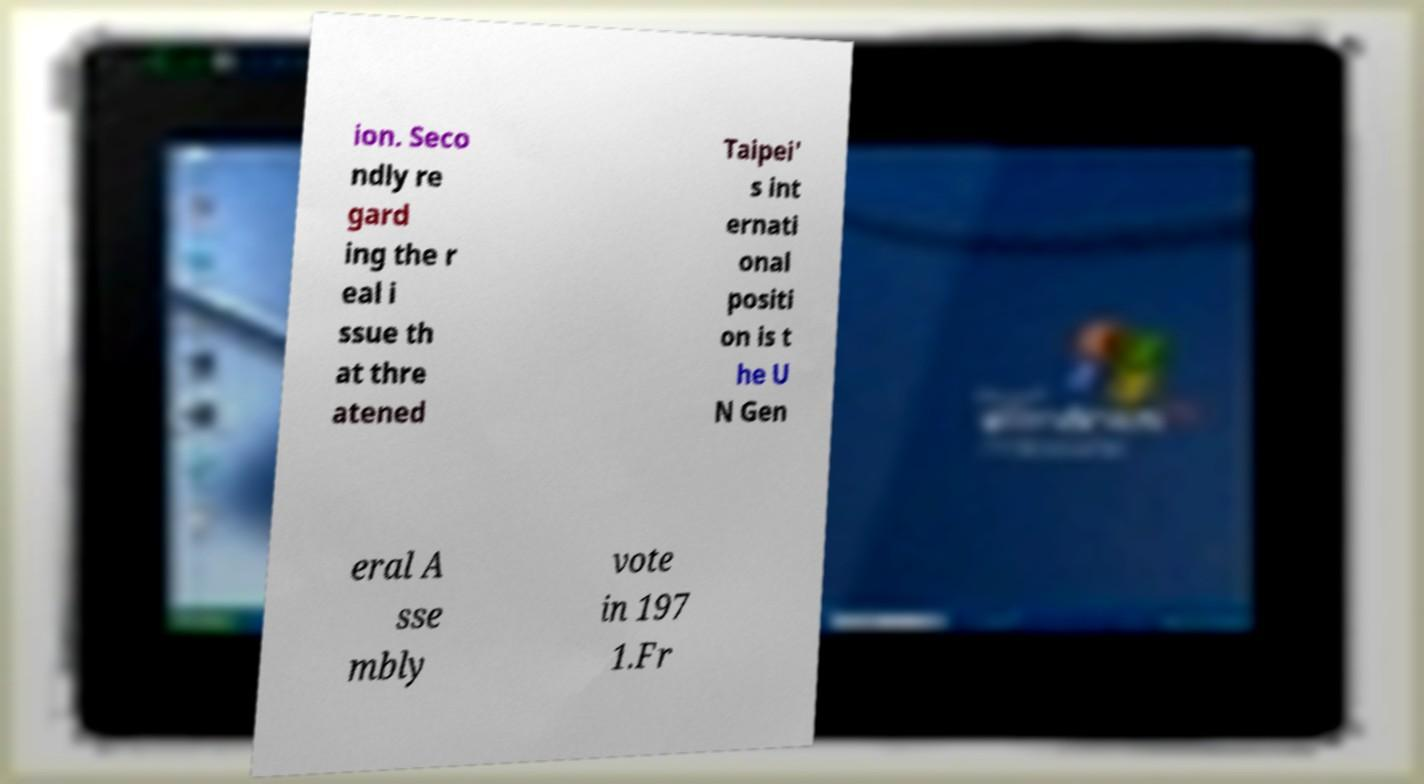What messages or text are displayed in this image? I need them in a readable, typed format. ion. Seco ndly re gard ing the r eal i ssue th at thre atened Taipei' s int ernati onal positi on is t he U N Gen eral A sse mbly vote in 197 1.Fr 